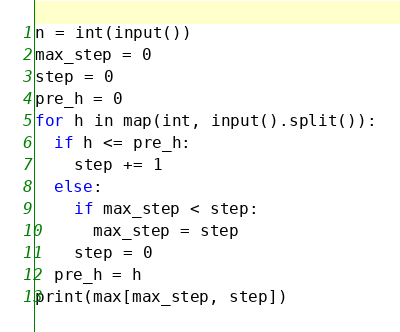<code> <loc_0><loc_0><loc_500><loc_500><_Python_>n = int(input())
max_step = 0
step = 0
pre_h = 0
for h in map(int, input().split()):
  if h <= pre_h:
    step += 1
  else:
    if max_step < step:
      max_step = step
    step = 0
  pre_h = h
print(max[max_step, step])</code> 